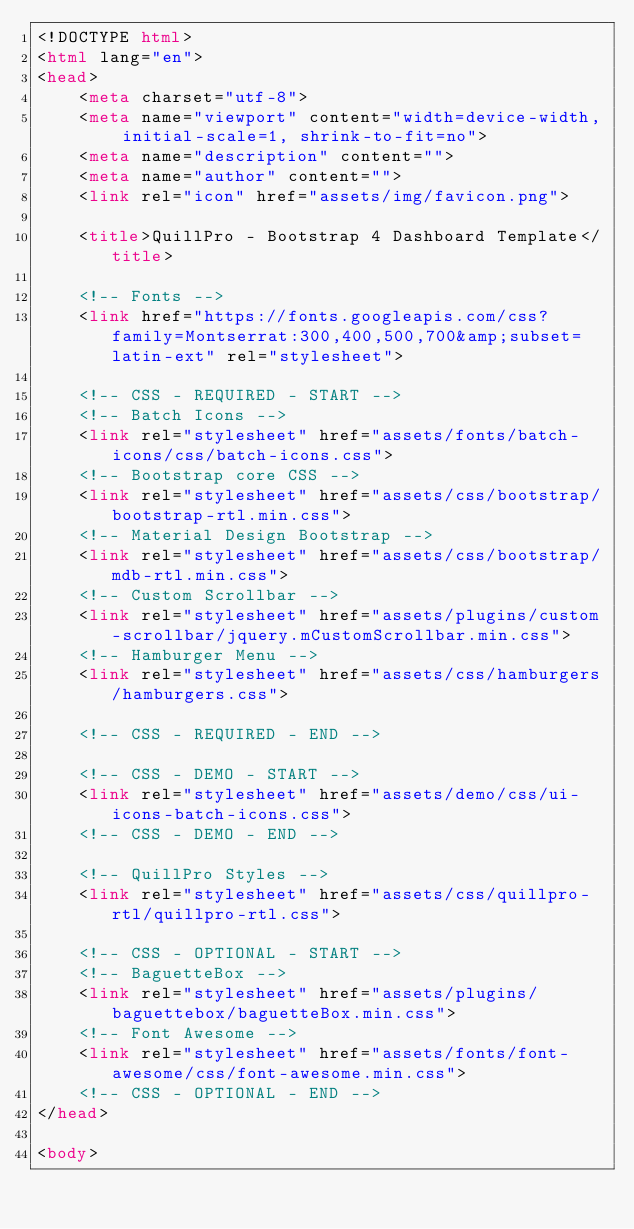Convert code to text. <code><loc_0><loc_0><loc_500><loc_500><_HTML_><!DOCTYPE html>
<html lang="en">
<head>
	<meta charset="utf-8">
	<meta name="viewport" content="width=device-width, initial-scale=1, shrink-to-fit=no">
	<meta name="description" content="">
	<meta name="author" content="">
	<link rel="icon" href="assets/img/favicon.png">

	<title>QuillPro - Bootstrap 4 Dashboard Template</title>

	<!-- Fonts -->
	<link href="https://fonts.googleapis.com/css?family=Montserrat:300,400,500,700&amp;subset=latin-ext" rel="stylesheet">

	<!-- CSS - REQUIRED - START -->
	<!-- Batch Icons -->
	<link rel="stylesheet" href="assets/fonts/batch-icons/css/batch-icons.css">
	<!-- Bootstrap core CSS -->
	<link rel="stylesheet" href="assets/css/bootstrap/bootstrap-rtl.min.css">
	<!-- Material Design Bootstrap -->
	<link rel="stylesheet" href="assets/css/bootstrap/mdb-rtl.min.css">
	<!-- Custom Scrollbar -->
	<link rel="stylesheet" href="assets/plugins/custom-scrollbar/jquery.mCustomScrollbar.min.css">
	<!-- Hamburger Menu -->
	<link rel="stylesheet" href="assets/css/hamburgers/hamburgers.css">

	<!-- CSS - REQUIRED - END -->

	<!-- CSS - DEMO - START -->
	<link rel="stylesheet" href="assets/demo/css/ui-icons-batch-icons.css">
	<!-- CSS - DEMO - END -->

	<!-- QuillPro Styles -->
	<link rel="stylesheet" href="assets/css/quillpro-rtl/quillpro-rtl.css">

	<!-- CSS - OPTIONAL - START -->
	<!-- BaguetteBox -->
	<link rel="stylesheet" href="assets/plugins/baguettebox/baguetteBox.min.css">
	<!-- Font Awesome -->
	<link rel="stylesheet" href="assets/fonts/font-awesome/css/font-awesome.min.css">
	<!-- CSS - OPTIONAL - END -->
</head>

<body>
</code> 